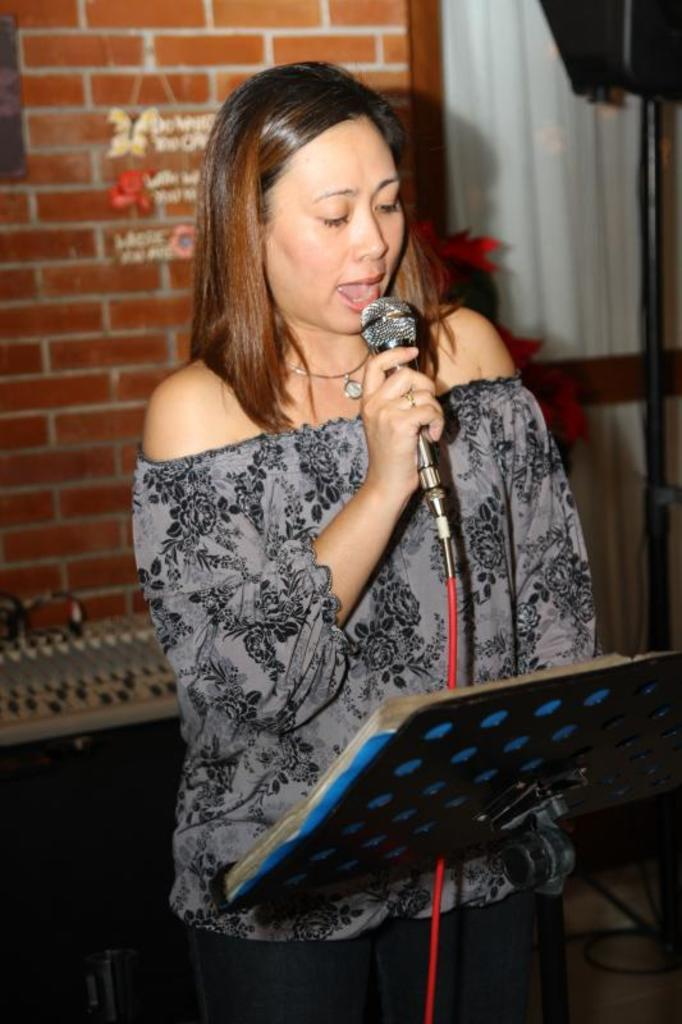What is the woman in the image doing? The woman is standing and singing in the image. What is the woman holding while singing? The woman is holding a microphone. Can you describe the person in front of the singer? There is another woman in front of the singer. What object can be seen on a stand in the image? There is a stand with a book on it. What can be seen in the background of the image? There is a brick wall and a curtain in the background. Reasoning: Let'g: Let's think step by step in order to produce the conversation. We start by identifying the main subject in the image, which is the woman singing. Then, we expand the conversation to include other details about her actions and the objects around her, such as the microphone, the person in front of her, the book on the stand, and the background elements. Each question is designed to elicit a specific detail about the image that is known from the provided facts. Absurd Question/Answer: What type of fang can be seen in the image? There is no fang present in the image. Are there any ghosts visible in the image? There are no ghosts visible in the image. 